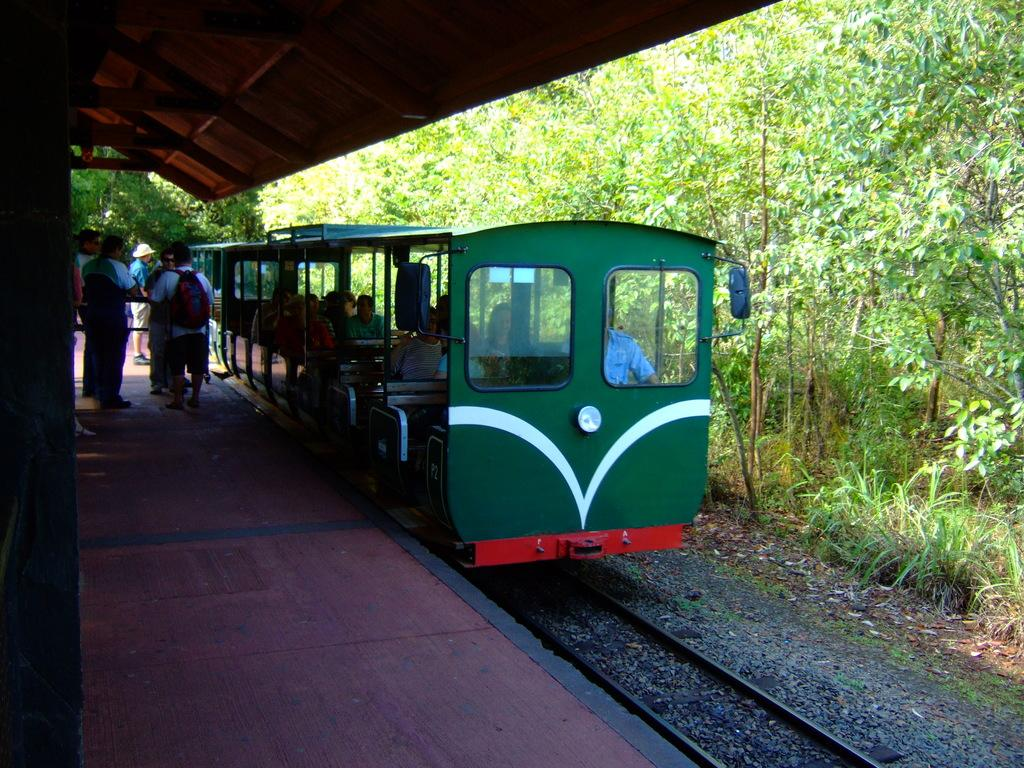What is the main subject of the image? The main subject of the image is a train. Where is the train located in the image? The train is on a track. What can be seen beside the train? There is a platform beside the train. Who is present on the platform? People are standing on the platform. What is visible in the background of the image? There are trees in the background of the image. What type of ornament is hanging from the train in the image? There is no ornament hanging from the train in the image. Are there any masks visible on the people standing on the platform? There is no mention of masks in the image; people are simply standing on the platform. 